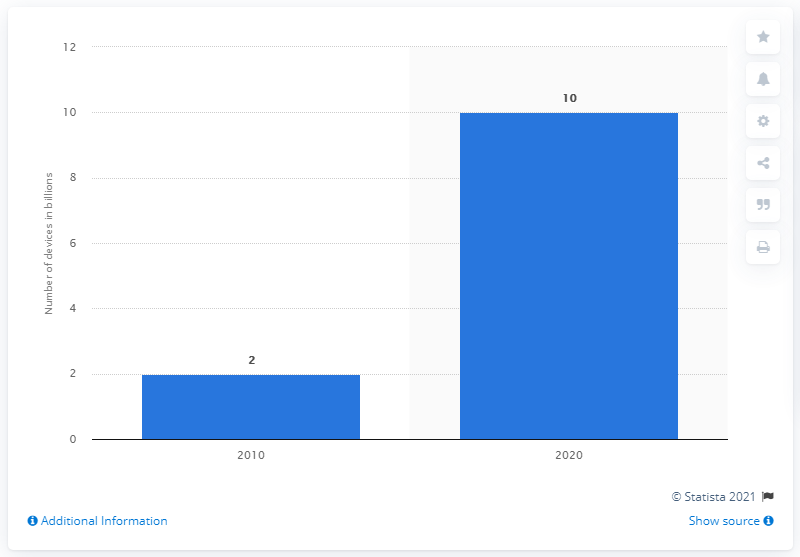Indicate a few pertinent items in this graphic. By 2020, it is expected that there will be approximately 10 mobile internet devices in use. 